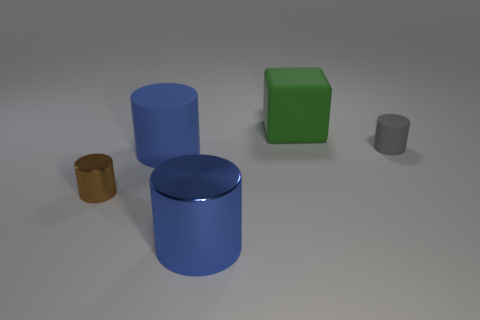Is the number of big blue objects that are behind the green thing the same as the number of blue metal cylinders in front of the gray matte cylinder?
Provide a succinct answer. No. What number of other objects are the same material as the small brown cylinder?
Offer a very short reply. 1. Is the number of blue things that are on the right side of the big blue rubber thing the same as the number of small gray rubber objects?
Make the answer very short. Yes. There is a cube; does it have the same size as the rubber object left of the blue metal cylinder?
Provide a succinct answer. Yes. The big green thing that is to the right of the big blue matte thing has what shape?
Your answer should be very brief. Cube. Is there anything else that is the same shape as the blue matte object?
Give a very brief answer. Yes. Are there any big blue rubber objects?
Your answer should be very brief. Yes. Is the size of the matte cylinder that is right of the blue metal cylinder the same as the rubber object to the left of the large block?
Ensure brevity in your answer.  No. There is a cylinder that is both on the left side of the large rubber cube and right of the big blue matte thing; what material is it?
Provide a short and direct response. Metal. There is a small brown thing; how many tiny objects are in front of it?
Your answer should be compact. 0. 